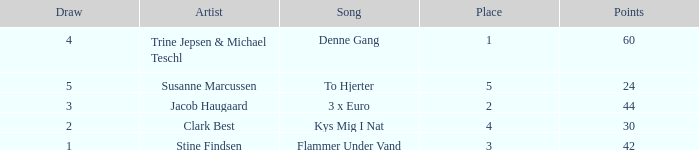What is the average Draw when the Place is larger than 5? None. 